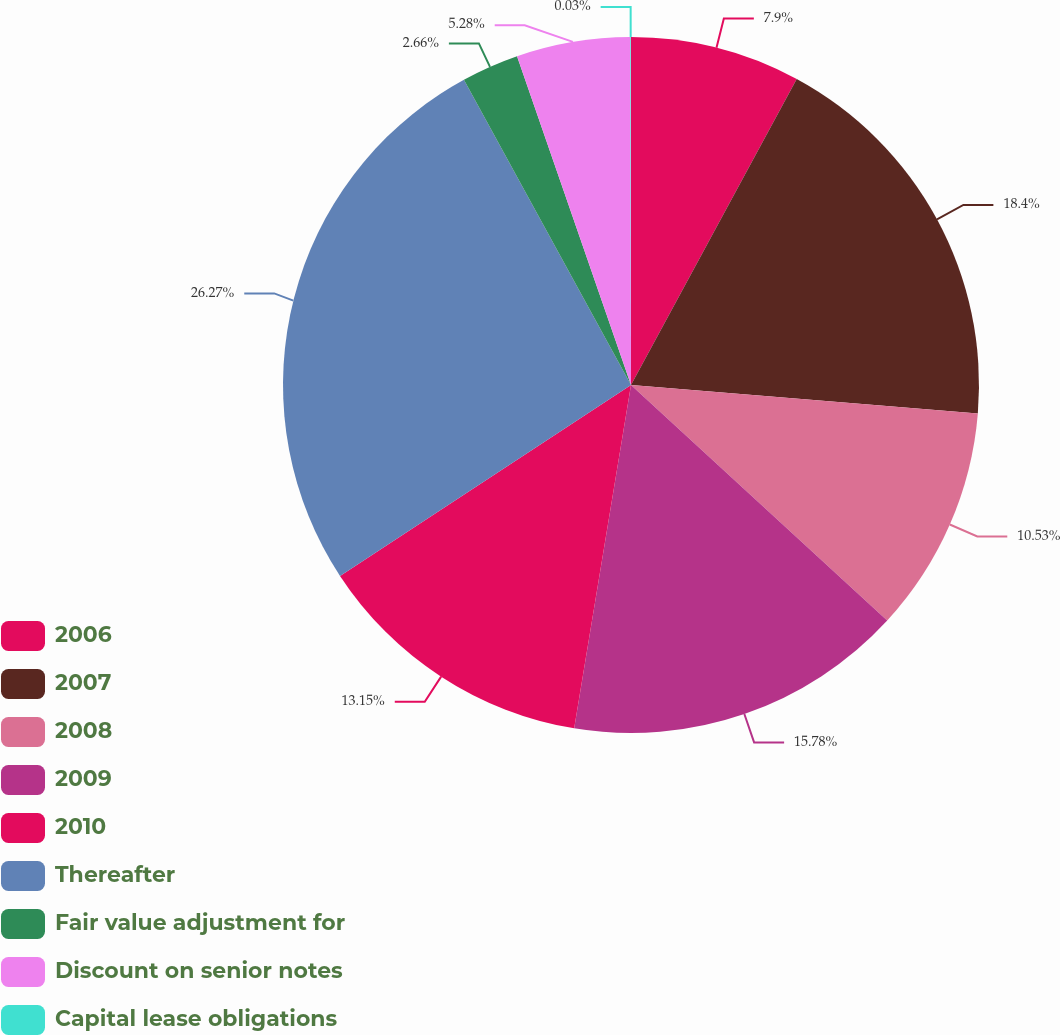<chart> <loc_0><loc_0><loc_500><loc_500><pie_chart><fcel>2006<fcel>2007<fcel>2008<fcel>2009<fcel>2010<fcel>Thereafter<fcel>Fair value adjustment for<fcel>Discount on senior notes<fcel>Capital lease obligations<nl><fcel>7.9%<fcel>18.4%<fcel>10.53%<fcel>15.78%<fcel>13.15%<fcel>26.27%<fcel>2.66%<fcel>5.28%<fcel>0.03%<nl></chart> 